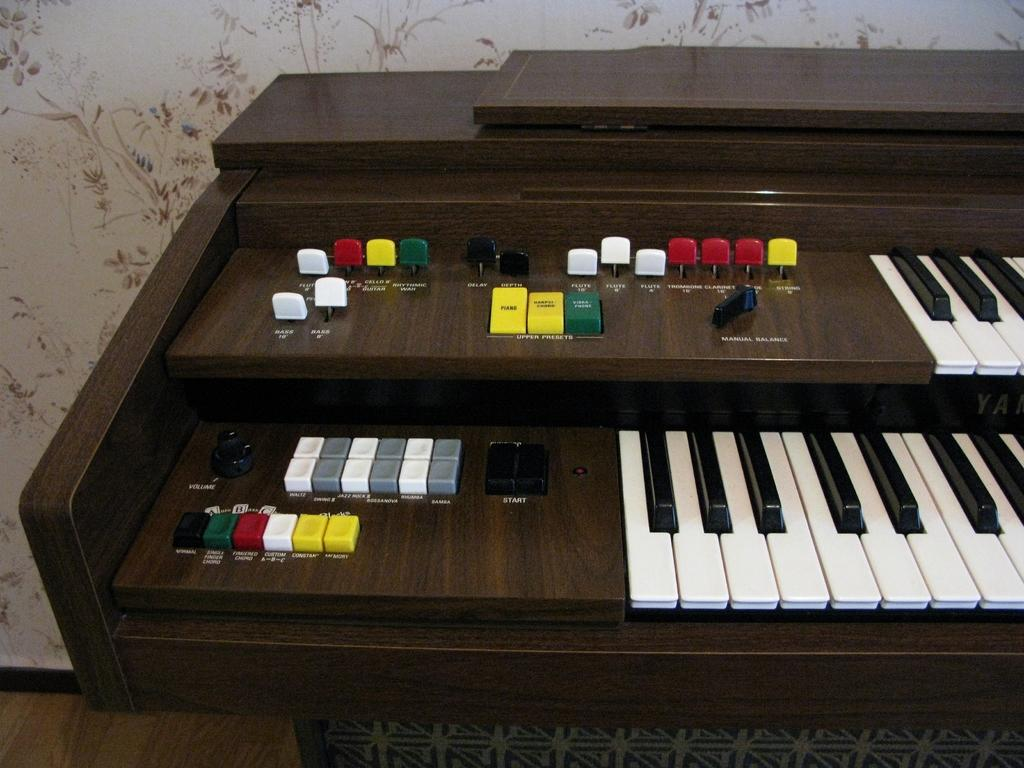What is the main subject of the image? The main subject of the image is a piano. What feature of the piano can be observed in the image? The piano has buttons of different colors. What specific colors are mentioned for the buttons? The colors mentioned are white, black, yellow, ash, red, and green. How many giants are playing the piano in the image? There are no giants present in the image; it features a piano with buttons of different colors. What type of cabbage is placed on top of the piano in the image? There is no cabbage present in the image; it only shows a piano with buttons of different colors. 